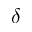Convert formula to latex. <formula><loc_0><loc_0><loc_500><loc_500>\delta</formula> 